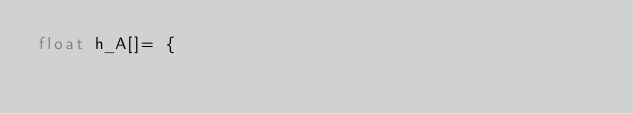Convert code to text. <code><loc_0><loc_0><loc_500><loc_500><_Cuda_>float h_A[]= {</code> 